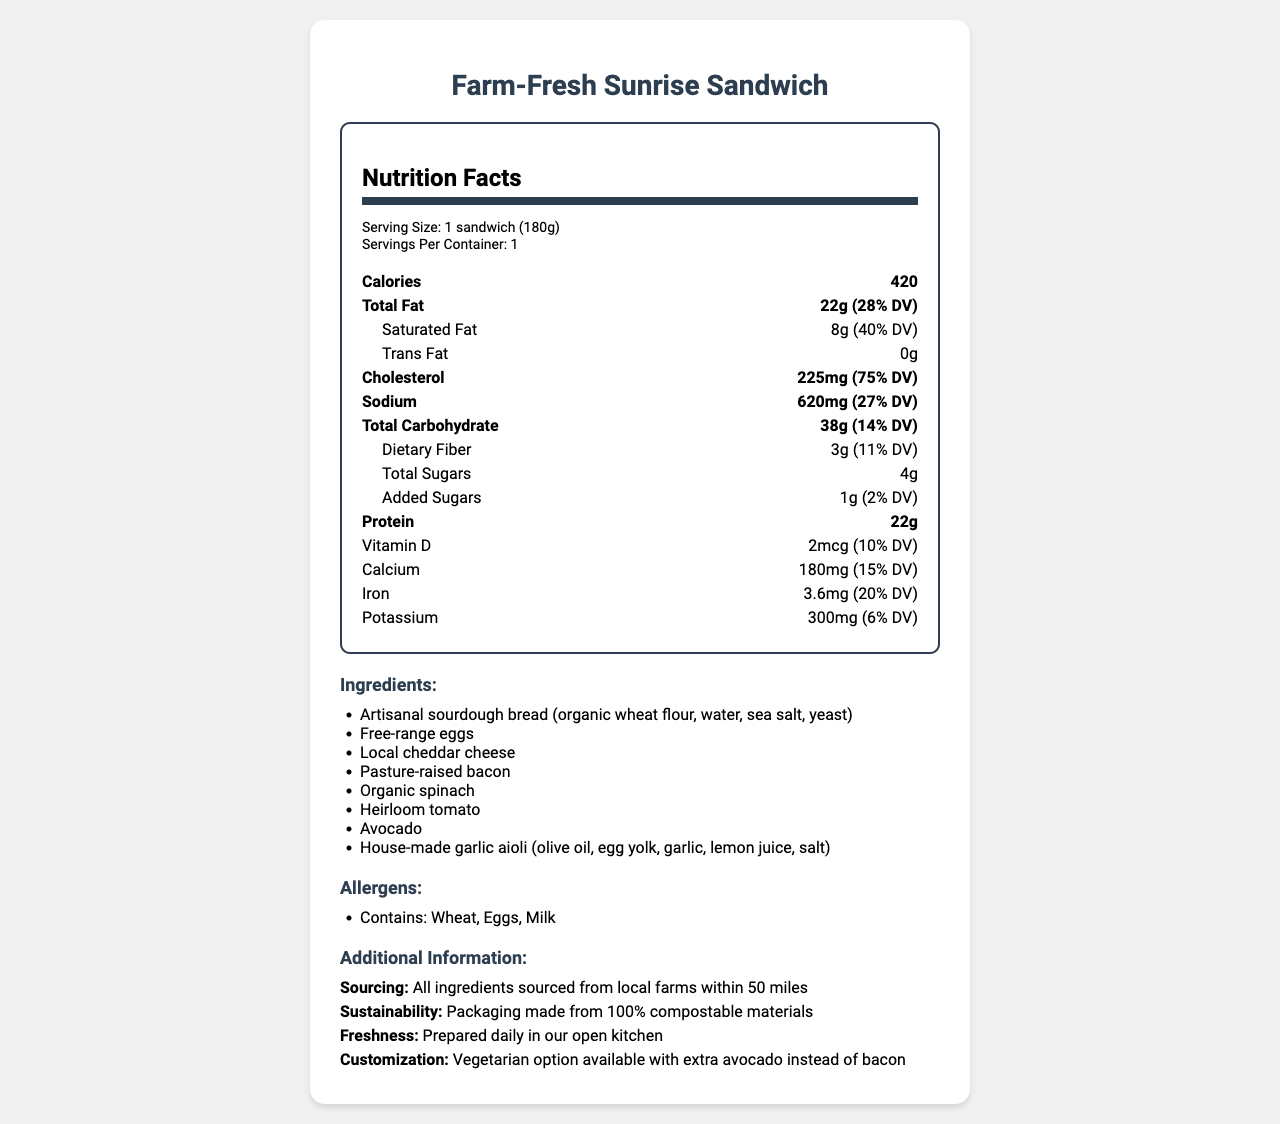what is the serving size for the Farm-Fresh Sunrise Sandwich? The serving size is clearly specified as 1 sandwich (180g) in the document under the "serving size" section.
Answer: 1 sandwich (180g) how many calories are in one Farm-Fresh Sunrise Sandwich? The document states that the sandwich contains 420 calories under the "Calories" section.
Answer: 420 how much saturated fat does the sandwich contain? The document details the amount of saturated fat as 8g under the "Saturated Fat" section.
Answer: 8g what ingredients are in the Farm-Fresh Sunrise Sandwich? The ingredients are listed under the "Ingredients" section in the document.
Answer: Artisanal sourdough bread, Free-range eggs, Local cheddar cheese, Pasture-raised bacon, Organic spinach, Heirloom tomato, Avocado, House-made garlic aioli what allergens are present in the Farm-Fresh Sunrise Sandwich? The allergens are listed under the "Allergens" section in the document.
Answer: Wheat, Eggs, Milk how much sodium is in one serving of the sandwich? The document specifies the sodium content as 620mg in the "Sodium" section.
Answer: 620mg what is the daily value percentage for dietary fiber in the sandwich? The percentage daily value for dietary fiber is listed as 11% in the document.
Answer: 11% how much protein does the sandwich provide? A. 15g B. 20g C. 22g D. 25g The document specifies that the sandwich contains 22g of protein.
Answer: C what is the daily value percentage for calcium in the sandwich? A. 6% B. 10% C. 15% D. 20% Calcium is listed as having a daily value percentage of 15%.
Answer: C is the packaging of the sandwich made from compostable materials? The additional information section states that the packaging is made from 100% compostable materials.
Answer: Yes does the sandwich contain any trans fat? The document clearly states that the sandwich contains 0g of trans fat.
Answer: No describe the main idea of the document. The document aims to offer a comprehensive overview of the nutritional value and other relevant information for the Farm-Fresh Sunrise Sandwich.
Answer: The document provides detailed nutrition facts for the Farm-Fresh Sunrise Sandwich, including information on calories, fats, cholesterol, sodium, carbohydrates, protein, vitamins, and minerals. It also lists the ingredients and allergens and provides additional details about sourcing, sustainability, freshness, and customization options. where do the ingredients for the sandwich come from? The document states that ingredients are sourced from local farms within 50 miles but does not specify exact names or locations of the farms.
Answer: Not enough information 